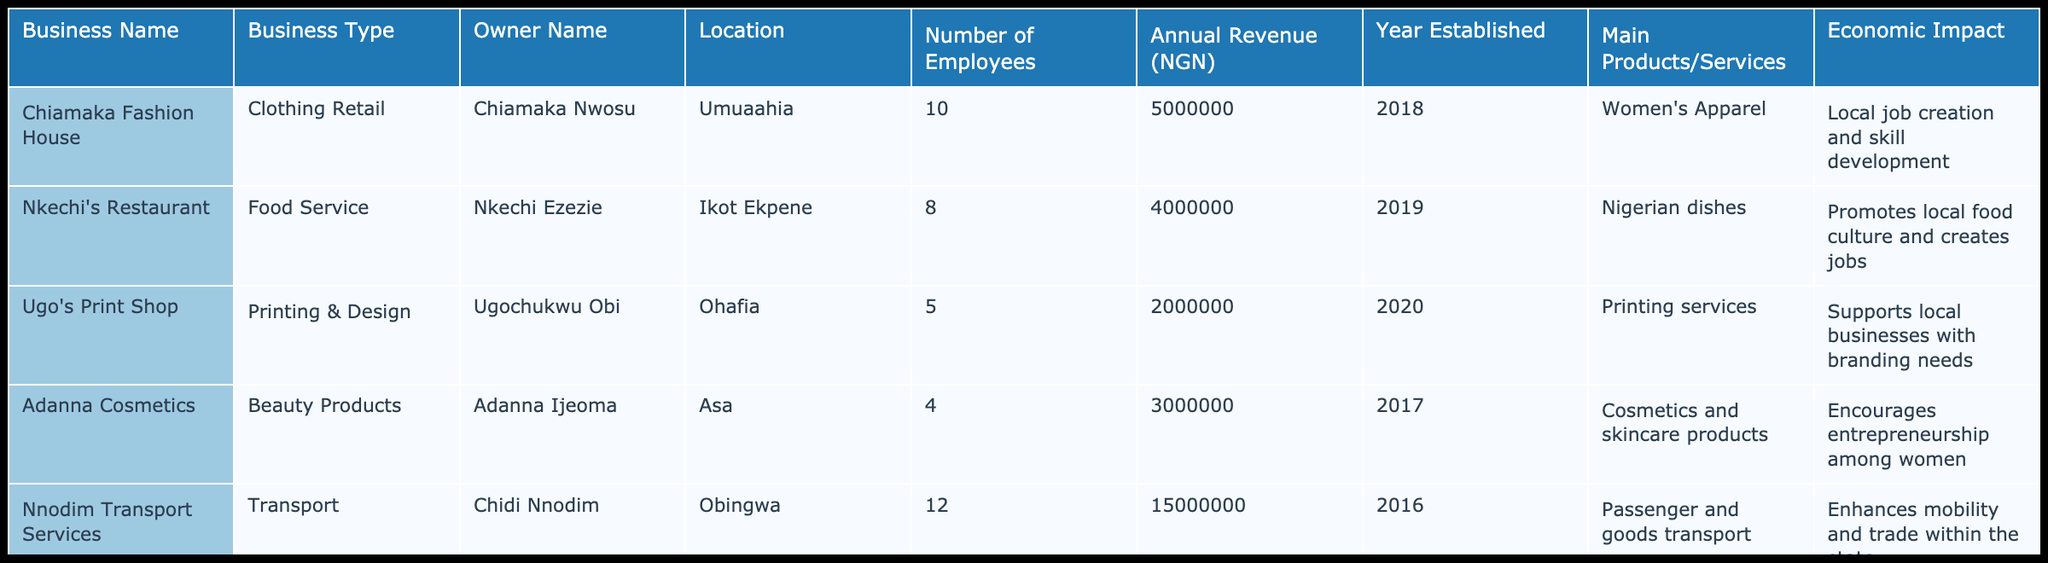What type of business has the highest annual revenue? Looking through the table, Kingsley Construction has an annual revenue of 30,000,000 NGN, which is the highest compared to the other businesses listed.
Answer: Kingsley Construction Which business type has the least number of employees? Adanna Cosmetics has the least number of employees, with only 4 employees. This is directly observable from the "Number of Employees" column.
Answer: Beauty Products What is the average annual revenue of all businesses listed? To find the average annual revenue, I will sum the revenues of all businesses: 5,000,000 + 4,000,000 + 2,000,000 + 3,000,000 + 15,000,000 + 6,000,000 + 30,000,000 = 65,000,000 NGN. Then divide by 7 (the number of businesses): 65,000,000 / 7 = 9,285,714.29 NGN (approximately).
Answer: 9,285,714.29 NGN Does Nkechi's Restaurant have a higher annual revenue than Ifeoma's Bakery? Comparing the annual revenues, Nkechi's Restaurant has 4,000,000 NGN while Ifeoma's Bakery has 6,000,000 NGN. Since 4,000,000 is less than 6,000,000, the statement is false.
Answer: No Which location has the most businesses listed in the table? Upon reviewing the locations, Umuahia (Chiamaka Fashion House) and Obingwa (Nnodim Transport Services) both have one business. The other locations (Ikot Ekpene, Ohafia, Asa, Isikwuato, Umukabia) also have one business each. Thus, no location has more than one business listed.
Answer: No location has more businesses 